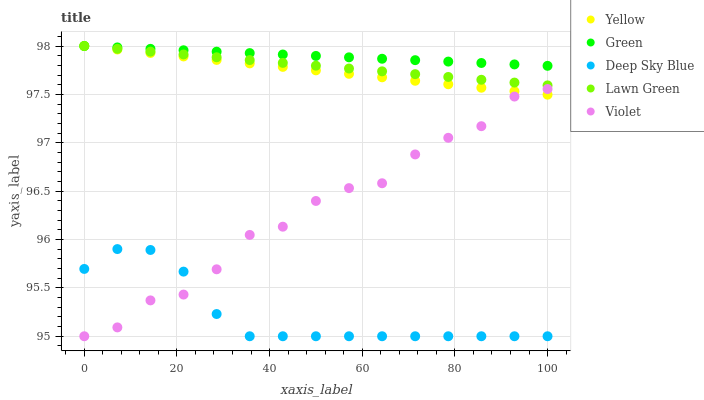Does Deep Sky Blue have the minimum area under the curve?
Answer yes or no. Yes. Does Green have the maximum area under the curve?
Answer yes or no. Yes. Does Green have the minimum area under the curve?
Answer yes or no. No. Does Deep Sky Blue have the maximum area under the curve?
Answer yes or no. No. Is Lawn Green the smoothest?
Answer yes or no. Yes. Is Violet the roughest?
Answer yes or no. Yes. Is Green the smoothest?
Answer yes or no. No. Is Green the roughest?
Answer yes or no. No. Does Deep Sky Blue have the lowest value?
Answer yes or no. Yes. Does Green have the lowest value?
Answer yes or no. No. Does Yellow have the highest value?
Answer yes or no. Yes. Does Deep Sky Blue have the highest value?
Answer yes or no. No. Is Deep Sky Blue less than Yellow?
Answer yes or no. Yes. Is Lawn Green greater than Deep Sky Blue?
Answer yes or no. Yes. Does Violet intersect Deep Sky Blue?
Answer yes or no. Yes. Is Violet less than Deep Sky Blue?
Answer yes or no. No. Is Violet greater than Deep Sky Blue?
Answer yes or no. No. Does Deep Sky Blue intersect Yellow?
Answer yes or no. No. 